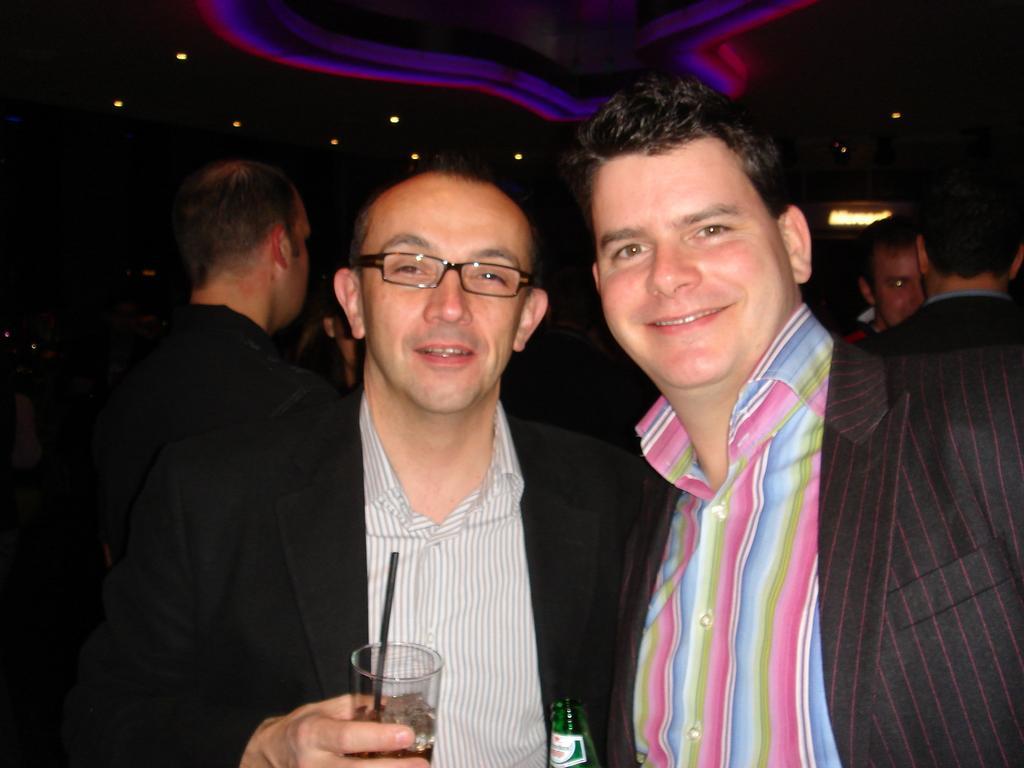How would you summarize this image in a sentence or two? In this image we can see some people standing on the ground. One person is holding a glass containing a straw. One man is holding a bottle. At the top of the image we can see some lights on the roof. 